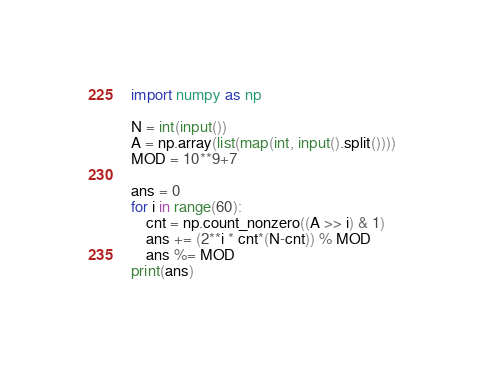<code> <loc_0><loc_0><loc_500><loc_500><_Python_>import numpy as np

N = int(input())
A = np.array(list(map(int, input().split())))
MOD = 10**9+7

ans = 0
for i in range(60):
    cnt = np.count_nonzero((A >> i) & 1)
    ans += (2**i * cnt*(N-cnt)) % MOD
    ans %= MOD
print(ans)
</code> 